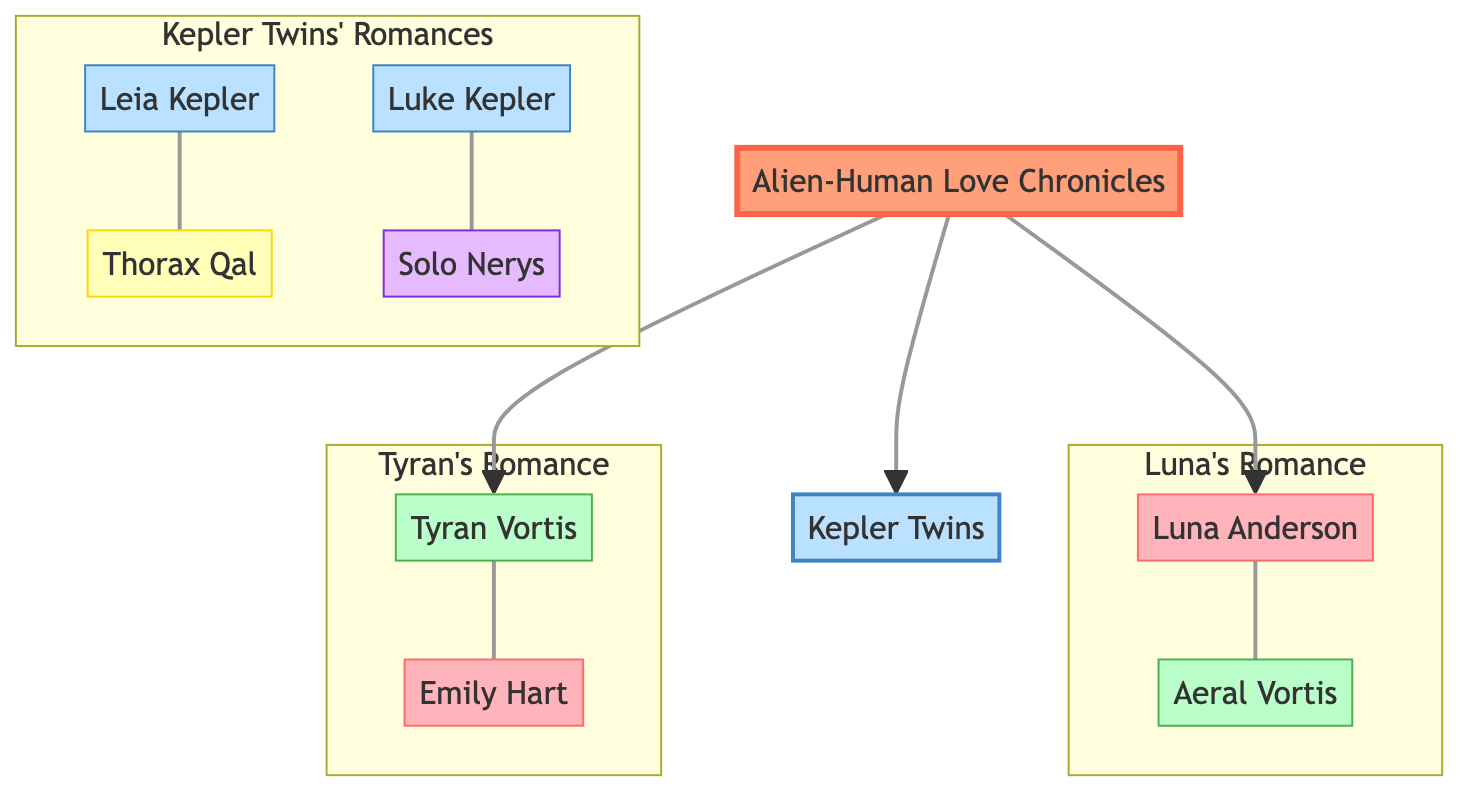What is the name of the founder of the family tree? The root node of the diagram identifies the founder as "Alien-Human Love Chronicles."
Answer: Alien-Human Love Chronicles How many children does the founder have? Counting the nodes directly under the root node (the founder), there are three children: Luna Anderson, Tyran Vortis, and Kepler Twins.
Answer: 3 Who is Luna Anderson's partner? The "key_romance" details under Luna Anderson indicate that her partner is Aeral Vortis.
Answer: Aeral Vortis What species is Tyran Vortis? The details under Tyran Vortis specify his species as "Zetarian."
Answer: Zetarian What traditions are associated with Leia Kepler's romance? Examining the details provided for Leia Kepler's partner indicates that the traditions include "Star-Gazing Fests" and "Heartlight Ceremonies."
Answer: Star-Gazing Fests, Heartlight Ceremonies Who has a hybrid species in this family tree? Looking at the details of the children, both the Kepler Twins (Leia and Luke) are designated as having a hybrid species.
Answer: Kepler Twins Which node represents the Earth cultural influence? Reviewing all nodes, Luna Anderson and Emily Hart are associated with the cultural influence of Earth.
Answer: Luna Anderson, Emily Hart What relationship does Thorax Qal have with Leia Kepler? Analyzing the diagram, Thorax Qal is identified as the partner of Leia Kepler, which denotes a romantic relationship.
Answer: Partner How many key romances are represented in the Kepler Twins section? The Kepler Twins section includes details for two key romances, one for Leia and one for Luke.
Answer: 2 This family tree includes which key alien cultures? Reviewing the details of the relationships, the tree includes influences from Antarean, Zetarian, and Teralian cultures.
Answer: Antarean, Zetarian, Teralian 